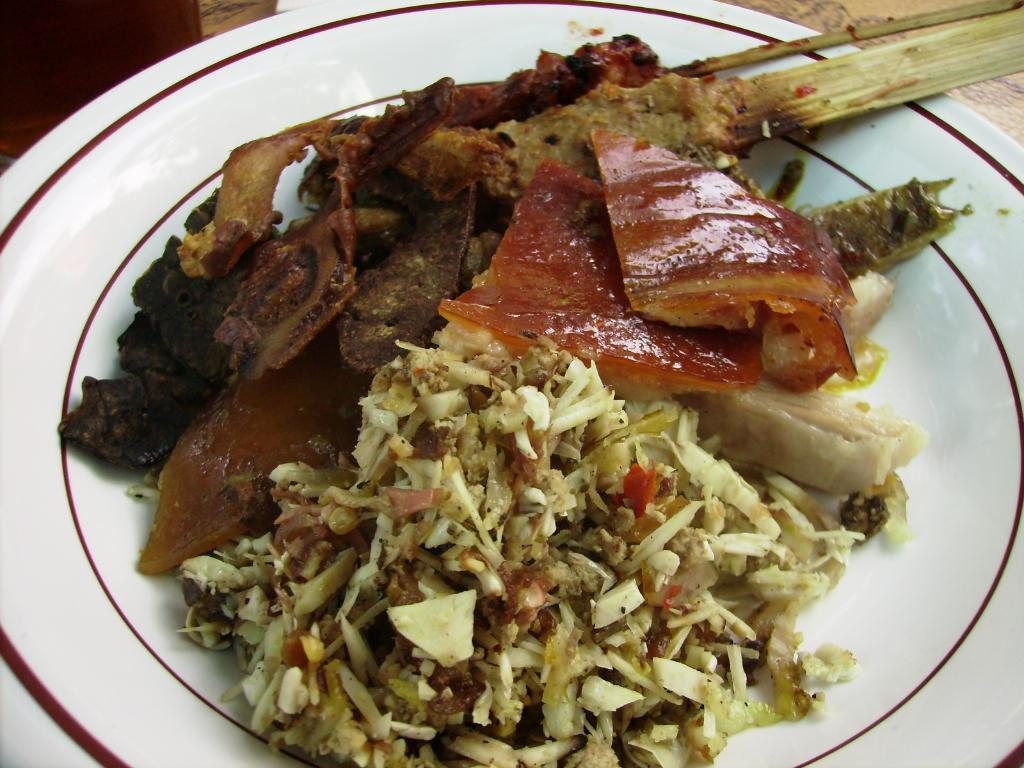Can you describe this image briefly? In this picture we can observe some food places in the plate. The plate is in white color. This plate is placed on the brown color table. 